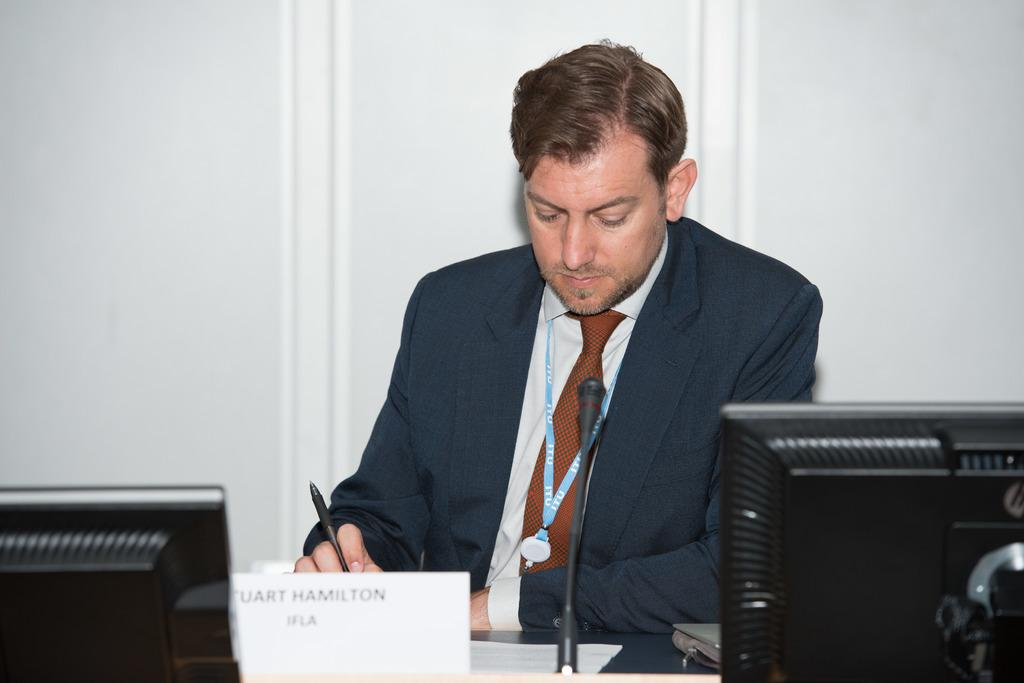Who or what is in the image? There is a person in the image. What is the person doing or standing near? The person is in front of a table. What is the person holding in his hand? The person is holding a pen in his hand. What objects can be seen on the table? The table contains monitors and a mic. What time of day is the person competing in the image? There is no indication of a competition or a specific time of day in the image. 